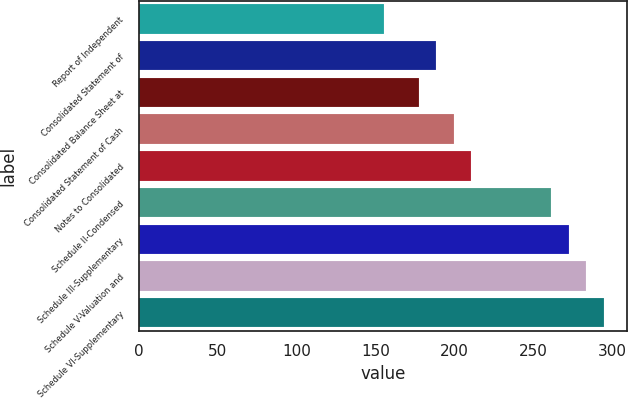Convert chart. <chart><loc_0><loc_0><loc_500><loc_500><bar_chart><fcel>Report of Independent<fcel>Consolidated Statement of<fcel>Consolidated Balance Sheet at<fcel>Consolidated Statement of Cash<fcel>Notes to Consolidated<fcel>Schedule II-Condensed<fcel>Schedule III-Supplementary<fcel>Schedule V-Valuation and<fcel>Schedule VI-Supplementary<nl><fcel>155<fcel>188.3<fcel>177.2<fcel>199.4<fcel>210.5<fcel>261<fcel>272.1<fcel>283.2<fcel>294.3<nl></chart> 